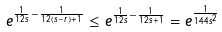<formula> <loc_0><loc_0><loc_500><loc_500>e ^ { \frac { 1 } { 1 2 s } - \frac { 1 } { 1 2 ( s - r ) + 1 } } \leq e ^ { \frac { 1 } { 1 2 s } - \frac { 1 } { 1 2 s + 1 } } = e ^ { \frac { 1 } { 1 4 4 s ^ { 2 } } }</formula> 